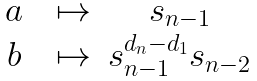<formula> <loc_0><loc_0><loc_500><loc_500>\begin{matrix} & a & & \mapsto & s _ { n - 1 } & \\ & b & & \mapsto & s _ { n - 1 } ^ { d _ { n } - d _ { 1 } } s _ { n - 2 } & \end{matrix}</formula> 